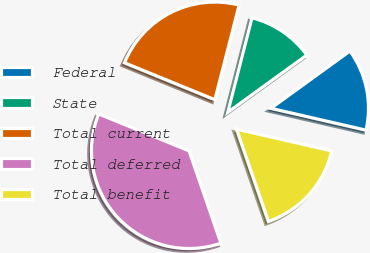Convert chart to OTSL. <chart><loc_0><loc_0><loc_500><loc_500><pie_chart><fcel>Federal<fcel>State<fcel>Total current<fcel>Total deferred<fcel>Total benefit<nl><fcel>13.57%<fcel>11.03%<fcel>22.82%<fcel>36.46%<fcel>16.12%<nl></chart> 